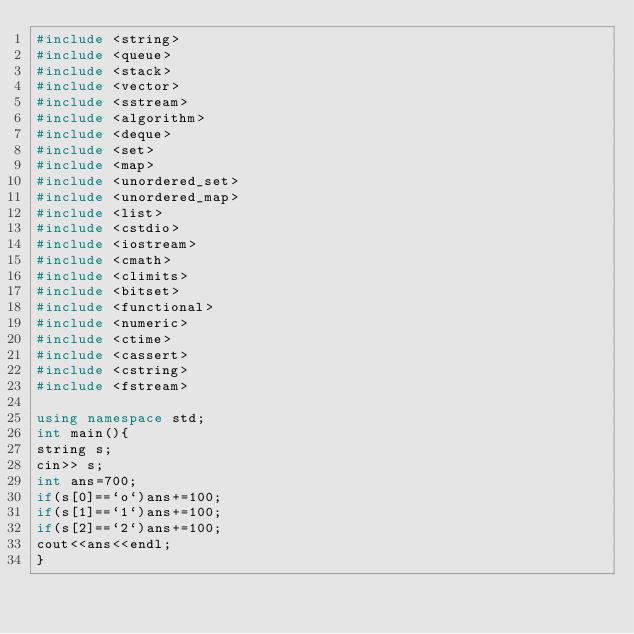Convert code to text. <code><loc_0><loc_0><loc_500><loc_500><_C++_>#include <string>
#include <queue>
#include <stack>
#include <vector>
#include <sstream>
#include <algorithm>
#include <deque>
#include <set>
#include <map>
#include <unordered_set>
#include <unordered_map>
#include <list>
#include <cstdio>
#include <iostream>
#include <cmath>
#include <climits>
#include <bitset>
#include <functional>
#include <numeric>
#include <ctime>
#include <cassert>
#include <cstring>
#include <fstream>
 
using namespace std;
int main(){
string s;
cin>> s;
int ans=700;
if(s[0]==`o`)ans+=100;
if(s[1]==`1`)ans+=100;
if(s[2]==`2`)ans+=100;
cout<<ans<<endl;
}
</code> 